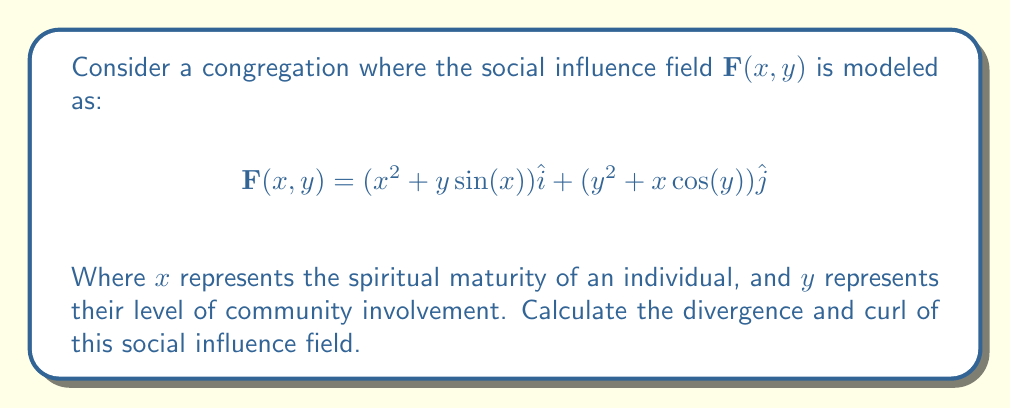Provide a solution to this math problem. To solve this problem, we need to calculate the divergence and curl of the given vector field.

1. Divergence:
The divergence of a vector field $\mathbf{F}(x,y) = P(x,y)\hat{i} + Q(x,y)\hat{j}$ is given by:

$$\nabla \cdot \mathbf{F} = \frac{\partial P}{\partial x} + \frac{\partial Q}{\partial y}$$

Here, $P(x,y) = x^2 + y\sin(x)$ and $Q(x,y) = y^2 + x\cos(y)$

$$\frac{\partial P}{\partial x} = 2x + y\cos(x)$$
$$\frac{\partial Q}{\partial y} = 2y - x\sin(y)$$

Therefore, the divergence is:

$$\nabla \cdot \mathbf{F} = (2x + y\cos(x)) + (2y - x\sin(y)) = 2x + 2y + y\cos(x) - x\sin(y)$$

2. Curl:
The curl of a vector field $\mathbf{F}(x,y) = P(x,y)\hat{i} + Q(x,y)\hat{j}$ in 2D is given by:

$$\nabla \times \mathbf{F} = \left(\frac{\partial Q}{\partial x} - \frac{\partial P}{\partial y}\right)\hat{k}$$

$$\frac{\partial Q}{\partial x} = \cos(y)$$
$$\frac{\partial P}{\partial y} = \sin(x)$$

Therefore, the curl is:

$$\nabla \times \mathbf{F} = (\cos(y) - \sin(x))\hat{k}$$

These results show how the social influence changes with respect to spiritual maturity and community involvement in the congregation.
Answer: Divergence: $2x + 2y + y\cos(x) - x\sin(y)$
Curl: $(\cos(y) - \sin(x))\hat{k}$ 